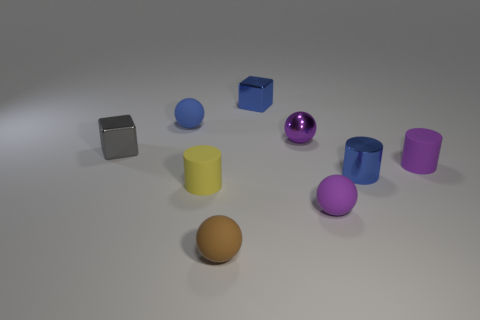Subtract all purple cubes. How many purple spheres are left? 2 Subtract all purple shiny balls. How many balls are left? 3 Subtract all blue balls. How many balls are left? 3 Subtract all balls. How many objects are left? 5 Subtract all cyan balls. Subtract all purple cylinders. How many balls are left? 4 Subtract all brown rubber objects. Subtract all shiny cylinders. How many objects are left? 7 Add 7 purple objects. How many purple objects are left? 10 Add 3 small brown matte spheres. How many small brown matte spheres exist? 4 Subtract 0 yellow balls. How many objects are left? 9 